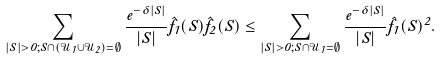Convert formula to latex. <formula><loc_0><loc_0><loc_500><loc_500>\sum _ { | S | > 0 ; S \cap ( \mathcal { U } _ { 1 } \cup \mathcal { U } _ { 2 } ) = \emptyset } \frac { e ^ { - \delta | S | } } { | S | } \hat { f } _ { 1 } ( S ) \hat { f } _ { 2 } ( S ) \leq \sum _ { | S | > 0 ; S \cap \mathcal { U } _ { 1 } = \emptyset } \frac { e ^ { - \delta | S | } } { | S | } \hat { f } _ { 1 } ( S ) ^ { 2 } .</formula> 